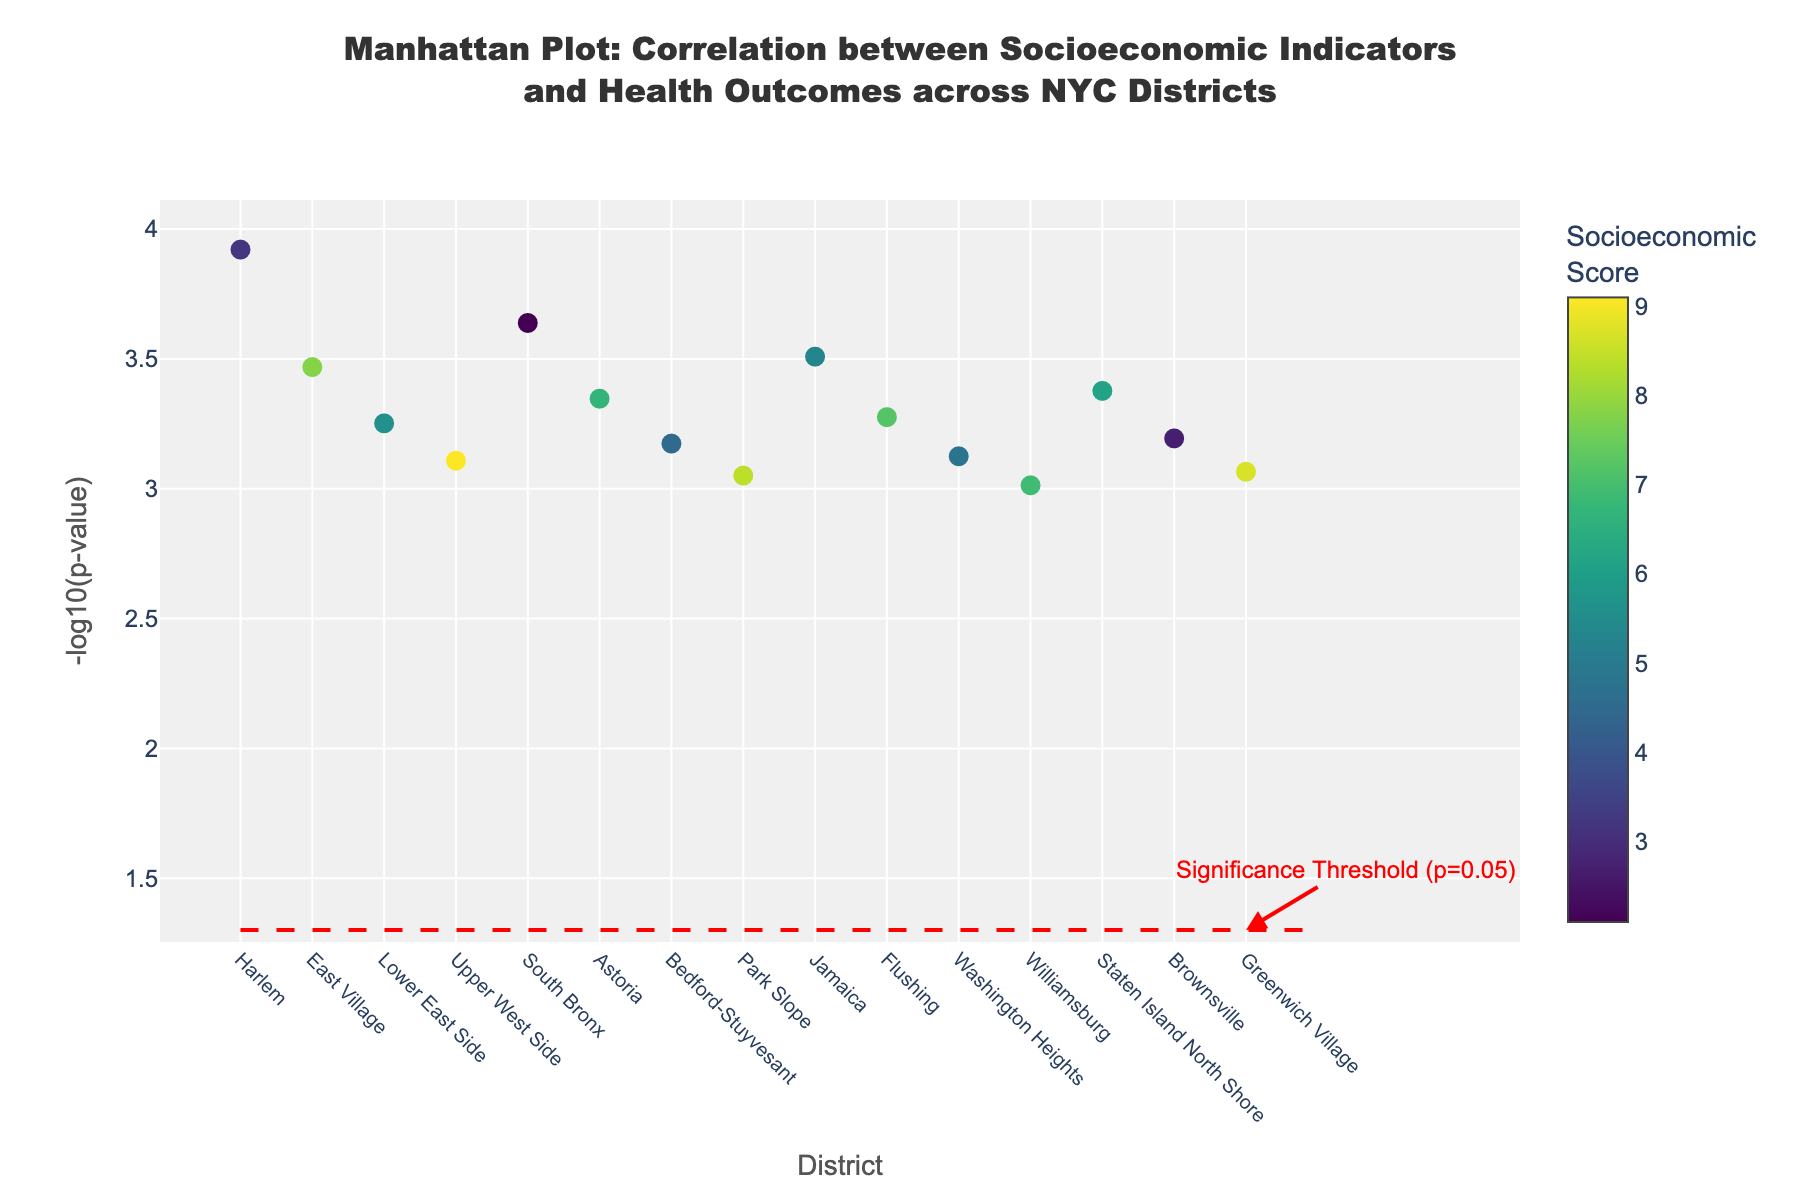What's the title of the plot? The title of the plot can be found at the top of the figure, and it generally summarizes what the plot is about. In this case, it is written in a bold font for emphasis.
Answer: Manhattan Plot: Correlation between Socioeconomic Indicators and Health Outcomes across NYC Districts How is the significance threshold represented in the plot? The significance threshold is often indicated with a line. Here, it's specifically marked by a horizontal dashed red line placed at -log10(0.05), which signifies the p-value of 0.05. An annotation also points it out.
Answer: A horizontal dashed red line What does the color of the markers represent in the plot? The colors of the markers are representing the socioeconomic scores. This is evident from the color bar titled 'Socioeconomic<br>Score'. Different colors correspond to different values on this scale.
Answer: Socioeconomic Score Which district has the highest -log10(p-value)? To find this, look for the marker that is the highest on the y-axis. According to the given data and visual inspection, the district with the highest value is East Harlem.
Answer: East Harlem How many districts are shown in the plot? The number of districts can be determined by counting the markers or checking the x-axis labels. According to the provided data, 15 districts are shown.
Answer: 15 Which district has the lowest health outcome score, and what is the score? The health outcome score can be found in the hover text when a marker is hovered over, or by cross-referencing the data points' text. Here, South Bronx has the lowest score of 2.8.
Answer: South Bronx, 2.8 Compare the socioeconomic score of Upper West Side and Park Slope. Which is higher? By looking at the color intensity and verifying against the color bar or exact values in the hover text, Upper West Side (score 9.1) can be compared to Park Slope (score 8.4). Upper West Side has a higher score.
Answer: Upper West Side Which district has a PValue closest to 0.0005? To find the district closest to this PValue, focus on the markers that are near the -log10(0.0005), which is roughly 3.30. From this close inspection, Lower East Side is nearest with its PValue of 0.00056.
Answer: Lower East Side Among the districts with a socioeconomic score lower than 3, which has the highest health outcome score? Focus on districts with socioeconomic scores less than 3 (also low-intensity colors), and compare their health outcome scores via hover text. South Bronx, with a health outcome score of 2.8, is the highest among these.
Answer: South Bronx 